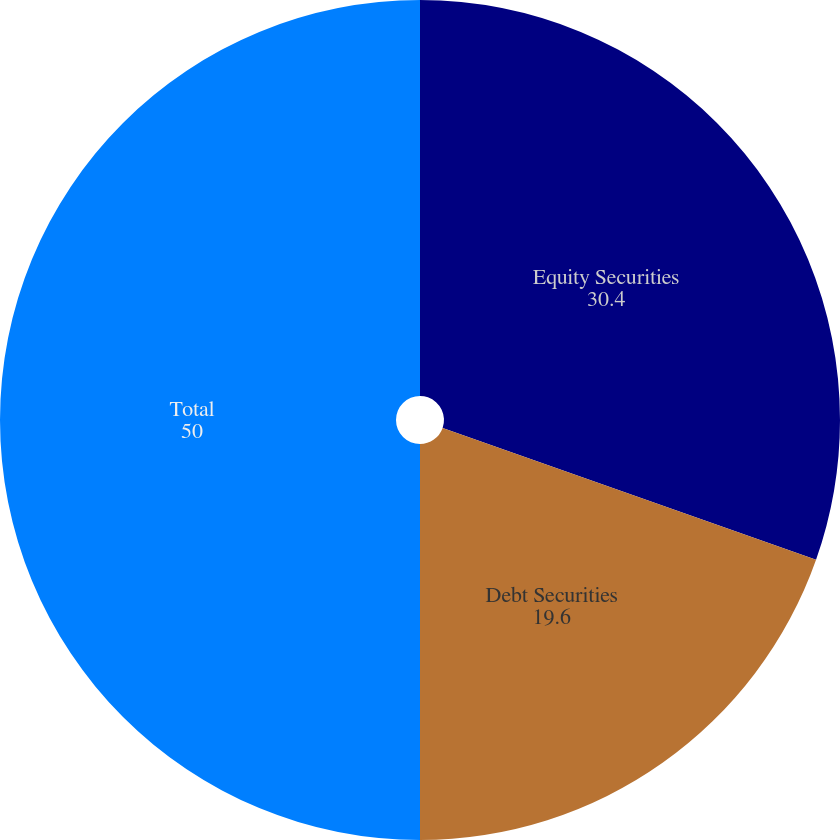Convert chart to OTSL. <chart><loc_0><loc_0><loc_500><loc_500><pie_chart><fcel>Equity Securities<fcel>Debt Securities<fcel>Total<nl><fcel>30.4%<fcel>19.6%<fcel>50.0%<nl></chart> 